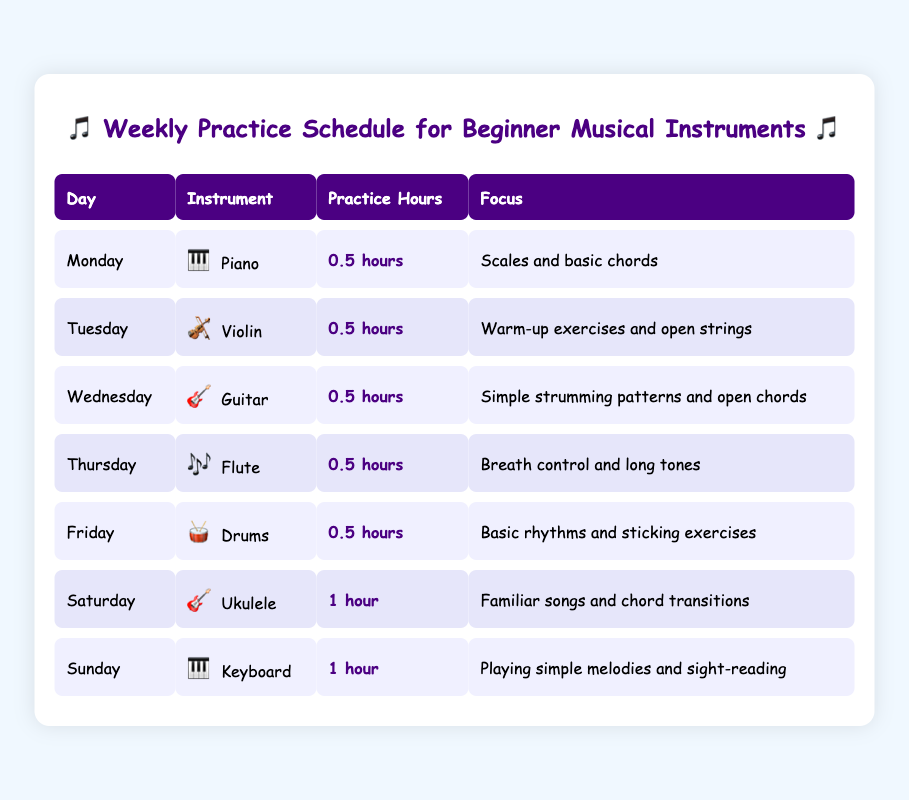What instrument does your child practice on Monday? On Monday, the instrument listed is Piano.
Answer: Piano How many practice hours are allocated for Tuesday's session? The practice hours for Tuesday, when the Violin is practiced, is 0.5 hours.
Answer: 0.5 hours What focus area does your child work on when practicing the Ukulele? The focus area for Ukulele practice on Saturday is familiar songs and chord transitions.
Answer: Familiar songs and chord transitions Which day has the longest practice session and how long is it? The longest practice session is on Saturday and Sunday, with each session lasting 1 hour.
Answer: 1 hour How many total practice hours are scheduled from Monday to Friday? The total practice hours from Monday to Friday are calculated by summing the hours: 0.5 (Piano) + 0.5 (Violin) + 0.5 (Guitar) + 0.5 (Flute) + 0.5 (Drums) = 2.5 hours.
Answer: 2.5 hours Is the focus on scales and basic chords scheduled for a weekend day? No, the focus on scales and basic chords is scheduled for Monday, which is a weekday.
Answer: No On which day is the Flute practiced? Flute practice is scheduled for Thursday.
Answer: Thursday What is the average practice time per day for the entire week? The average practice time per day is calculated by taking the total hours for the week: 0.5 + 0.5 + 0.5 + 0.5 + 0.5 + 1 + 1 = 5 hours, then dividing by the number of days (7): 5 hours / 7 days = approximately 0.71 hours.
Answer: Approximately 0.71 hours Does your child practice a string instrument more than once a week? No, your child practices string instruments (Violin and Ukulele) only once each during the week.
Answer: No 